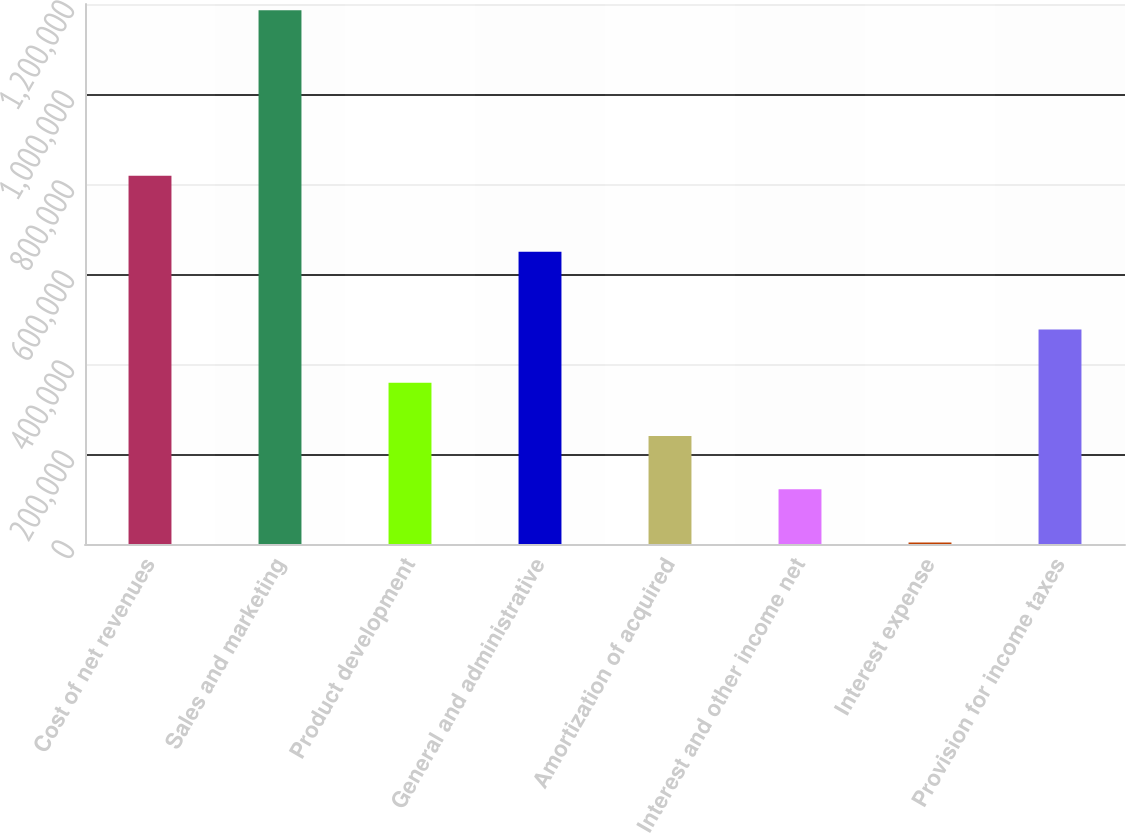Convert chart. <chart><loc_0><loc_0><loc_500><loc_500><bar_chart><fcel>Cost of net revenues<fcel>Sales and marketing<fcel>Product development<fcel>General and administrative<fcel>Amortization of acquired<fcel>Interest and other income net<fcel>Interest expense<fcel>Provision for income taxes<nl><fcel>818104<fcel>1.18593e+06<fcel>358213<fcel>649529<fcel>239968<fcel>121723<fcel>3478<fcel>476458<nl></chart> 